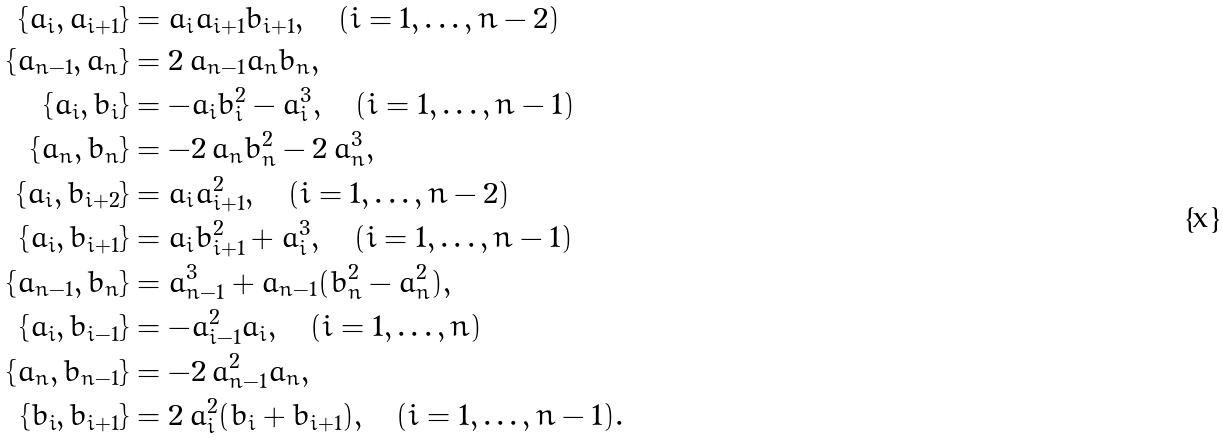<formula> <loc_0><loc_0><loc_500><loc_500>\{ a _ { i } , a _ { i + 1 } \} & = a _ { i } a _ { i + 1 } b _ { i + 1 } , \quad ( i = 1 , \dots , n - 2 ) \\ \{ a _ { n - 1 } , a _ { n } \} & = 2 \, a _ { n - 1 } a _ { n } b _ { n } , \\ \{ a _ { i } , b _ { i } \} & = - a _ { i } b _ { i } ^ { 2 } - a _ { i } ^ { 3 } , \quad ( i = 1 , \dots , n - 1 ) \\ \{ a _ { n } , b _ { n } \} & = - 2 \, a _ { n } b _ { n } ^ { 2 } - 2 \, a _ { n } ^ { 3 } , \\ \{ a _ { i } , b _ { i + 2 } \} & = a _ { i } a _ { i + 1 } ^ { 2 } , \quad ( i = 1 , \dots , n - 2 ) \\ \{ a _ { i } , b _ { i + 1 } \} & = a _ { i } b _ { i + 1 } ^ { 2 } + a _ { i } ^ { 3 } , \quad ( i = 1 , \dots , n - 1 ) \\ \{ a _ { n - 1 } , b _ { n } \} & = a _ { n - 1 } ^ { 3 } + a _ { n - 1 } ( b _ { n } ^ { 2 } - a _ { n } ^ { 2 } ) , \\ \{ a _ { i } , b _ { i - 1 } \} & = - a _ { i - 1 } ^ { 2 } a _ { i } , \quad ( i = 1 , \dots , n ) \\ \{ a _ { n } , b _ { n - 1 } \} & = - 2 \, a _ { n - 1 } ^ { 2 } a _ { n } , \\ \{ b _ { i } , b _ { i + 1 } \} & = 2 \, a _ { i } ^ { 2 } ( b _ { i } + b _ { i + 1 } ) , \quad ( i = 1 , \dots , n - 1 ) .</formula> 